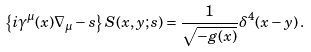Convert formula to latex. <formula><loc_0><loc_0><loc_500><loc_500>\left \{ i \gamma ^ { \mu } ( x ) \nabla _ { \mu } - s \right \} S ( x , y ; s ) = \frac { 1 } { \sqrt { - g ( x ) } } \delta ^ { 4 } ( x - y ) \, .</formula> 